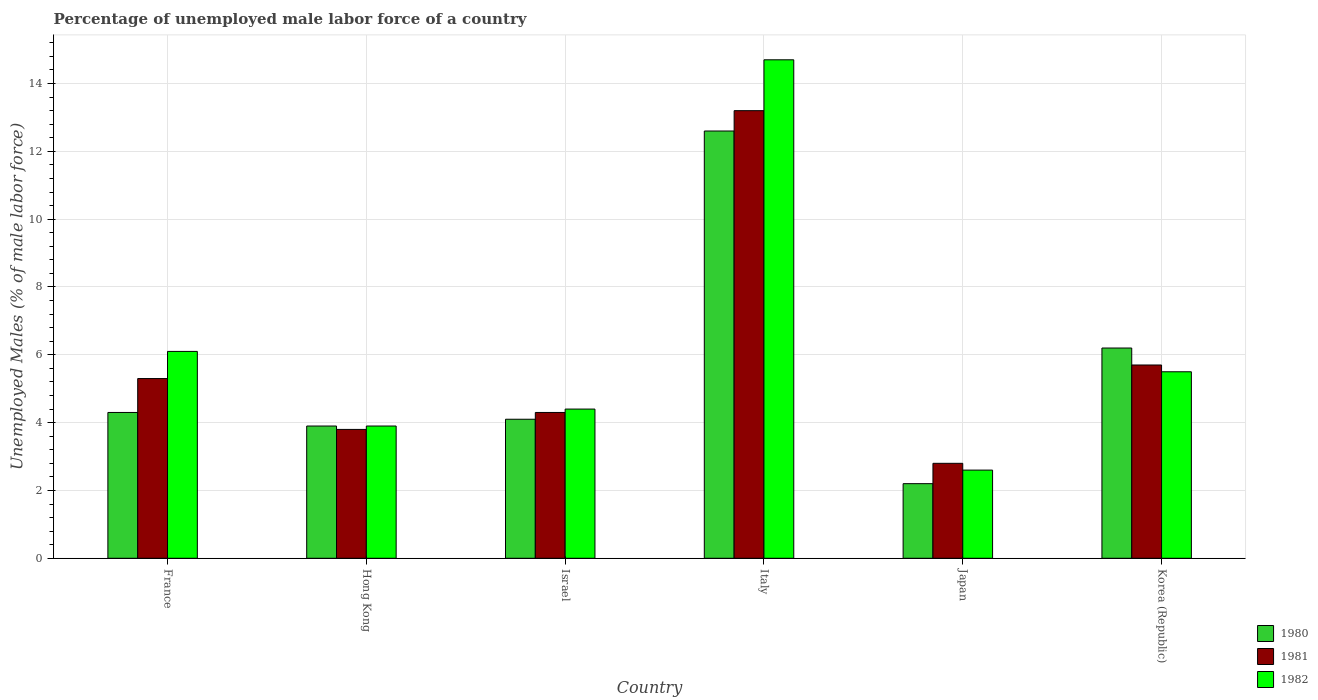How many different coloured bars are there?
Offer a terse response. 3. How many bars are there on the 5th tick from the right?
Offer a terse response. 3. What is the label of the 5th group of bars from the left?
Make the answer very short. Japan. In how many cases, is the number of bars for a given country not equal to the number of legend labels?
Your answer should be compact. 0. What is the percentage of unemployed male labor force in 1980 in Italy?
Your answer should be very brief. 12.6. Across all countries, what is the maximum percentage of unemployed male labor force in 1980?
Make the answer very short. 12.6. Across all countries, what is the minimum percentage of unemployed male labor force in 1981?
Your response must be concise. 2.8. In which country was the percentage of unemployed male labor force in 1982 maximum?
Your answer should be compact. Italy. What is the total percentage of unemployed male labor force in 1980 in the graph?
Your response must be concise. 33.3. What is the difference between the percentage of unemployed male labor force in 1981 in Italy and that in Japan?
Keep it short and to the point. 10.4. What is the difference between the percentage of unemployed male labor force in 1981 in Israel and the percentage of unemployed male labor force in 1982 in Italy?
Provide a short and direct response. -10.4. What is the average percentage of unemployed male labor force in 1981 per country?
Your answer should be compact. 5.85. What is the difference between the percentage of unemployed male labor force of/in 1980 and percentage of unemployed male labor force of/in 1982 in Israel?
Your response must be concise. -0.3. In how many countries, is the percentage of unemployed male labor force in 1980 greater than 0.8 %?
Your response must be concise. 6. What is the ratio of the percentage of unemployed male labor force in 1982 in Israel to that in Italy?
Give a very brief answer. 0.3. Is the percentage of unemployed male labor force in 1980 in Italy less than that in Korea (Republic)?
Your response must be concise. No. What is the difference between the highest and the second highest percentage of unemployed male labor force in 1981?
Ensure brevity in your answer.  -0.4. What is the difference between the highest and the lowest percentage of unemployed male labor force in 1981?
Offer a very short reply. 10.4. In how many countries, is the percentage of unemployed male labor force in 1982 greater than the average percentage of unemployed male labor force in 1982 taken over all countries?
Make the answer very short. 1. What does the 1st bar from the left in France represents?
Give a very brief answer. 1980. What does the 2nd bar from the right in Italy represents?
Offer a terse response. 1981. Are all the bars in the graph horizontal?
Make the answer very short. No. Are the values on the major ticks of Y-axis written in scientific E-notation?
Your response must be concise. No. Does the graph contain any zero values?
Provide a succinct answer. No. How are the legend labels stacked?
Your response must be concise. Vertical. What is the title of the graph?
Your answer should be very brief. Percentage of unemployed male labor force of a country. Does "1975" appear as one of the legend labels in the graph?
Your answer should be compact. No. What is the label or title of the X-axis?
Provide a succinct answer. Country. What is the label or title of the Y-axis?
Ensure brevity in your answer.  Unemployed Males (% of male labor force). What is the Unemployed Males (% of male labor force) of 1980 in France?
Your answer should be very brief. 4.3. What is the Unemployed Males (% of male labor force) in 1981 in France?
Keep it short and to the point. 5.3. What is the Unemployed Males (% of male labor force) in 1982 in France?
Offer a very short reply. 6.1. What is the Unemployed Males (% of male labor force) of 1980 in Hong Kong?
Provide a short and direct response. 3.9. What is the Unemployed Males (% of male labor force) of 1981 in Hong Kong?
Give a very brief answer. 3.8. What is the Unemployed Males (% of male labor force) of 1982 in Hong Kong?
Your answer should be very brief. 3.9. What is the Unemployed Males (% of male labor force) of 1980 in Israel?
Keep it short and to the point. 4.1. What is the Unemployed Males (% of male labor force) in 1981 in Israel?
Provide a short and direct response. 4.3. What is the Unemployed Males (% of male labor force) of 1982 in Israel?
Offer a terse response. 4.4. What is the Unemployed Males (% of male labor force) in 1980 in Italy?
Keep it short and to the point. 12.6. What is the Unemployed Males (% of male labor force) in 1981 in Italy?
Provide a short and direct response. 13.2. What is the Unemployed Males (% of male labor force) of 1982 in Italy?
Provide a short and direct response. 14.7. What is the Unemployed Males (% of male labor force) of 1980 in Japan?
Your answer should be compact. 2.2. What is the Unemployed Males (% of male labor force) in 1981 in Japan?
Ensure brevity in your answer.  2.8. What is the Unemployed Males (% of male labor force) in 1982 in Japan?
Make the answer very short. 2.6. What is the Unemployed Males (% of male labor force) of 1980 in Korea (Republic)?
Your response must be concise. 6.2. What is the Unemployed Males (% of male labor force) in 1981 in Korea (Republic)?
Your answer should be very brief. 5.7. Across all countries, what is the maximum Unemployed Males (% of male labor force) in 1980?
Offer a terse response. 12.6. Across all countries, what is the maximum Unemployed Males (% of male labor force) in 1981?
Offer a very short reply. 13.2. Across all countries, what is the maximum Unemployed Males (% of male labor force) in 1982?
Your response must be concise. 14.7. Across all countries, what is the minimum Unemployed Males (% of male labor force) of 1980?
Ensure brevity in your answer.  2.2. Across all countries, what is the minimum Unemployed Males (% of male labor force) of 1981?
Keep it short and to the point. 2.8. Across all countries, what is the minimum Unemployed Males (% of male labor force) in 1982?
Offer a very short reply. 2.6. What is the total Unemployed Males (% of male labor force) of 1980 in the graph?
Your answer should be very brief. 33.3. What is the total Unemployed Males (% of male labor force) of 1981 in the graph?
Ensure brevity in your answer.  35.1. What is the total Unemployed Males (% of male labor force) of 1982 in the graph?
Provide a succinct answer. 37.2. What is the difference between the Unemployed Males (% of male labor force) of 1982 in France and that in Hong Kong?
Provide a succinct answer. 2.2. What is the difference between the Unemployed Males (% of male labor force) of 1982 in France and that in Israel?
Keep it short and to the point. 1.7. What is the difference between the Unemployed Males (% of male labor force) of 1980 in France and that in Japan?
Keep it short and to the point. 2.1. What is the difference between the Unemployed Males (% of male labor force) of 1981 in France and that in Japan?
Your response must be concise. 2.5. What is the difference between the Unemployed Males (% of male labor force) in 1982 in France and that in Japan?
Your answer should be compact. 3.5. What is the difference between the Unemployed Males (% of male labor force) in 1980 in France and that in Korea (Republic)?
Keep it short and to the point. -1.9. What is the difference between the Unemployed Males (% of male labor force) in 1982 in France and that in Korea (Republic)?
Provide a succinct answer. 0.6. What is the difference between the Unemployed Males (% of male labor force) in 1980 in Hong Kong and that in Israel?
Keep it short and to the point. -0.2. What is the difference between the Unemployed Males (% of male labor force) in 1982 in Hong Kong and that in Italy?
Give a very brief answer. -10.8. What is the difference between the Unemployed Males (% of male labor force) of 1980 in Hong Kong and that in Japan?
Give a very brief answer. 1.7. What is the difference between the Unemployed Males (% of male labor force) of 1980 in Hong Kong and that in Korea (Republic)?
Keep it short and to the point. -2.3. What is the difference between the Unemployed Males (% of male labor force) of 1981 in Hong Kong and that in Korea (Republic)?
Offer a very short reply. -1.9. What is the difference between the Unemployed Males (% of male labor force) in 1982 in Hong Kong and that in Korea (Republic)?
Offer a very short reply. -1.6. What is the difference between the Unemployed Males (% of male labor force) of 1980 in Israel and that in Italy?
Keep it short and to the point. -8.5. What is the difference between the Unemployed Males (% of male labor force) in 1980 in Israel and that in Japan?
Provide a short and direct response. 1.9. What is the difference between the Unemployed Males (% of male labor force) of 1981 in Israel and that in Japan?
Your response must be concise. 1.5. What is the difference between the Unemployed Males (% of male labor force) in 1981 in Israel and that in Korea (Republic)?
Give a very brief answer. -1.4. What is the difference between the Unemployed Males (% of male labor force) in 1982 in Italy and that in Japan?
Keep it short and to the point. 12.1. What is the difference between the Unemployed Males (% of male labor force) in 1980 in Italy and that in Korea (Republic)?
Ensure brevity in your answer.  6.4. What is the difference between the Unemployed Males (% of male labor force) in 1980 in Japan and that in Korea (Republic)?
Offer a very short reply. -4. What is the difference between the Unemployed Males (% of male labor force) of 1981 in Japan and that in Korea (Republic)?
Offer a terse response. -2.9. What is the difference between the Unemployed Males (% of male labor force) in 1982 in Japan and that in Korea (Republic)?
Offer a terse response. -2.9. What is the difference between the Unemployed Males (% of male labor force) in 1980 in France and the Unemployed Males (% of male labor force) in 1982 in Israel?
Make the answer very short. -0.1. What is the difference between the Unemployed Males (% of male labor force) in 1981 in France and the Unemployed Males (% of male labor force) in 1982 in Israel?
Your response must be concise. 0.9. What is the difference between the Unemployed Males (% of male labor force) in 1980 in France and the Unemployed Males (% of male labor force) in 1981 in Italy?
Keep it short and to the point. -8.9. What is the difference between the Unemployed Males (% of male labor force) of 1980 in France and the Unemployed Males (% of male labor force) of 1982 in Italy?
Make the answer very short. -10.4. What is the difference between the Unemployed Males (% of male labor force) of 1980 in France and the Unemployed Males (% of male labor force) of 1982 in Japan?
Provide a short and direct response. 1.7. What is the difference between the Unemployed Males (% of male labor force) of 1980 in France and the Unemployed Males (% of male labor force) of 1982 in Korea (Republic)?
Ensure brevity in your answer.  -1.2. What is the difference between the Unemployed Males (% of male labor force) of 1980 in Hong Kong and the Unemployed Males (% of male labor force) of 1981 in Israel?
Your response must be concise. -0.4. What is the difference between the Unemployed Males (% of male labor force) of 1980 in Hong Kong and the Unemployed Males (% of male labor force) of 1981 in Italy?
Your answer should be compact. -9.3. What is the difference between the Unemployed Males (% of male labor force) in 1980 in Hong Kong and the Unemployed Males (% of male labor force) in 1981 in Japan?
Keep it short and to the point. 1.1. What is the difference between the Unemployed Males (% of male labor force) of 1980 in Hong Kong and the Unemployed Males (% of male labor force) of 1982 in Korea (Republic)?
Provide a short and direct response. -1.6. What is the difference between the Unemployed Males (% of male labor force) of 1981 in Israel and the Unemployed Males (% of male labor force) of 1982 in Italy?
Ensure brevity in your answer.  -10.4. What is the difference between the Unemployed Males (% of male labor force) in 1981 in Israel and the Unemployed Males (% of male labor force) in 1982 in Japan?
Offer a very short reply. 1.7. What is the difference between the Unemployed Males (% of male labor force) of 1980 in Israel and the Unemployed Males (% of male labor force) of 1981 in Korea (Republic)?
Ensure brevity in your answer.  -1.6. What is the difference between the Unemployed Males (% of male labor force) of 1980 in Israel and the Unemployed Males (% of male labor force) of 1982 in Korea (Republic)?
Provide a short and direct response. -1.4. What is the difference between the Unemployed Males (% of male labor force) of 1980 in Italy and the Unemployed Males (% of male labor force) of 1981 in Japan?
Offer a terse response. 9.8. What is the difference between the Unemployed Males (% of male labor force) in 1980 in Italy and the Unemployed Males (% of male labor force) in 1982 in Korea (Republic)?
Provide a succinct answer. 7.1. What is the difference between the Unemployed Males (% of male labor force) in 1981 in Japan and the Unemployed Males (% of male labor force) in 1982 in Korea (Republic)?
Provide a succinct answer. -2.7. What is the average Unemployed Males (% of male labor force) in 1980 per country?
Make the answer very short. 5.55. What is the average Unemployed Males (% of male labor force) in 1981 per country?
Offer a very short reply. 5.85. What is the difference between the Unemployed Males (% of male labor force) in 1980 and Unemployed Males (% of male labor force) in 1981 in France?
Offer a terse response. -1. What is the difference between the Unemployed Males (% of male labor force) in 1980 and Unemployed Males (% of male labor force) in 1982 in France?
Provide a short and direct response. -1.8. What is the difference between the Unemployed Males (% of male labor force) of 1980 and Unemployed Males (% of male labor force) of 1981 in Hong Kong?
Give a very brief answer. 0.1. What is the difference between the Unemployed Males (% of male labor force) in 1981 and Unemployed Males (% of male labor force) in 1982 in Hong Kong?
Offer a very short reply. -0.1. What is the difference between the Unemployed Males (% of male labor force) in 1980 and Unemployed Males (% of male labor force) in 1982 in Israel?
Your response must be concise. -0.3. What is the difference between the Unemployed Males (% of male labor force) in 1981 and Unemployed Males (% of male labor force) in 1982 in Korea (Republic)?
Ensure brevity in your answer.  0.2. What is the ratio of the Unemployed Males (% of male labor force) of 1980 in France to that in Hong Kong?
Offer a very short reply. 1.1. What is the ratio of the Unemployed Males (% of male labor force) of 1981 in France to that in Hong Kong?
Keep it short and to the point. 1.39. What is the ratio of the Unemployed Males (% of male labor force) of 1982 in France to that in Hong Kong?
Ensure brevity in your answer.  1.56. What is the ratio of the Unemployed Males (% of male labor force) of 1980 in France to that in Israel?
Give a very brief answer. 1.05. What is the ratio of the Unemployed Males (% of male labor force) of 1981 in France to that in Israel?
Offer a terse response. 1.23. What is the ratio of the Unemployed Males (% of male labor force) in 1982 in France to that in Israel?
Make the answer very short. 1.39. What is the ratio of the Unemployed Males (% of male labor force) in 1980 in France to that in Italy?
Offer a very short reply. 0.34. What is the ratio of the Unemployed Males (% of male labor force) in 1981 in France to that in Italy?
Your answer should be very brief. 0.4. What is the ratio of the Unemployed Males (% of male labor force) of 1982 in France to that in Italy?
Make the answer very short. 0.41. What is the ratio of the Unemployed Males (% of male labor force) in 1980 in France to that in Japan?
Provide a succinct answer. 1.95. What is the ratio of the Unemployed Males (% of male labor force) of 1981 in France to that in Japan?
Provide a short and direct response. 1.89. What is the ratio of the Unemployed Males (% of male labor force) in 1982 in France to that in Japan?
Offer a terse response. 2.35. What is the ratio of the Unemployed Males (% of male labor force) of 1980 in France to that in Korea (Republic)?
Your answer should be very brief. 0.69. What is the ratio of the Unemployed Males (% of male labor force) in 1981 in France to that in Korea (Republic)?
Offer a very short reply. 0.93. What is the ratio of the Unemployed Males (% of male labor force) in 1982 in France to that in Korea (Republic)?
Your response must be concise. 1.11. What is the ratio of the Unemployed Males (% of male labor force) in 1980 in Hong Kong to that in Israel?
Provide a short and direct response. 0.95. What is the ratio of the Unemployed Males (% of male labor force) in 1981 in Hong Kong to that in Israel?
Provide a short and direct response. 0.88. What is the ratio of the Unemployed Males (% of male labor force) in 1982 in Hong Kong to that in Israel?
Offer a very short reply. 0.89. What is the ratio of the Unemployed Males (% of male labor force) of 1980 in Hong Kong to that in Italy?
Ensure brevity in your answer.  0.31. What is the ratio of the Unemployed Males (% of male labor force) of 1981 in Hong Kong to that in Italy?
Provide a succinct answer. 0.29. What is the ratio of the Unemployed Males (% of male labor force) of 1982 in Hong Kong to that in Italy?
Your answer should be very brief. 0.27. What is the ratio of the Unemployed Males (% of male labor force) of 1980 in Hong Kong to that in Japan?
Give a very brief answer. 1.77. What is the ratio of the Unemployed Males (% of male labor force) of 1981 in Hong Kong to that in Japan?
Give a very brief answer. 1.36. What is the ratio of the Unemployed Males (% of male labor force) in 1980 in Hong Kong to that in Korea (Republic)?
Your answer should be compact. 0.63. What is the ratio of the Unemployed Males (% of male labor force) in 1981 in Hong Kong to that in Korea (Republic)?
Provide a short and direct response. 0.67. What is the ratio of the Unemployed Males (% of male labor force) in 1982 in Hong Kong to that in Korea (Republic)?
Keep it short and to the point. 0.71. What is the ratio of the Unemployed Males (% of male labor force) of 1980 in Israel to that in Italy?
Your answer should be compact. 0.33. What is the ratio of the Unemployed Males (% of male labor force) in 1981 in Israel to that in Italy?
Provide a succinct answer. 0.33. What is the ratio of the Unemployed Males (% of male labor force) of 1982 in Israel to that in Italy?
Offer a very short reply. 0.3. What is the ratio of the Unemployed Males (% of male labor force) in 1980 in Israel to that in Japan?
Give a very brief answer. 1.86. What is the ratio of the Unemployed Males (% of male labor force) of 1981 in Israel to that in Japan?
Make the answer very short. 1.54. What is the ratio of the Unemployed Males (% of male labor force) in 1982 in Israel to that in Japan?
Keep it short and to the point. 1.69. What is the ratio of the Unemployed Males (% of male labor force) of 1980 in Israel to that in Korea (Republic)?
Make the answer very short. 0.66. What is the ratio of the Unemployed Males (% of male labor force) in 1981 in Israel to that in Korea (Republic)?
Your response must be concise. 0.75. What is the ratio of the Unemployed Males (% of male labor force) of 1982 in Israel to that in Korea (Republic)?
Give a very brief answer. 0.8. What is the ratio of the Unemployed Males (% of male labor force) in 1980 in Italy to that in Japan?
Ensure brevity in your answer.  5.73. What is the ratio of the Unemployed Males (% of male labor force) of 1981 in Italy to that in Japan?
Provide a short and direct response. 4.71. What is the ratio of the Unemployed Males (% of male labor force) of 1982 in Italy to that in Japan?
Your answer should be very brief. 5.65. What is the ratio of the Unemployed Males (% of male labor force) of 1980 in Italy to that in Korea (Republic)?
Provide a succinct answer. 2.03. What is the ratio of the Unemployed Males (% of male labor force) in 1981 in Italy to that in Korea (Republic)?
Your answer should be compact. 2.32. What is the ratio of the Unemployed Males (% of male labor force) in 1982 in Italy to that in Korea (Republic)?
Offer a very short reply. 2.67. What is the ratio of the Unemployed Males (% of male labor force) of 1980 in Japan to that in Korea (Republic)?
Your answer should be very brief. 0.35. What is the ratio of the Unemployed Males (% of male labor force) of 1981 in Japan to that in Korea (Republic)?
Make the answer very short. 0.49. What is the ratio of the Unemployed Males (% of male labor force) in 1982 in Japan to that in Korea (Republic)?
Your response must be concise. 0.47. What is the difference between the highest and the second highest Unemployed Males (% of male labor force) of 1981?
Offer a very short reply. 7.5. What is the difference between the highest and the second highest Unemployed Males (% of male labor force) of 1982?
Keep it short and to the point. 8.6. What is the difference between the highest and the lowest Unemployed Males (% of male labor force) of 1981?
Offer a terse response. 10.4. What is the difference between the highest and the lowest Unemployed Males (% of male labor force) in 1982?
Your answer should be compact. 12.1. 